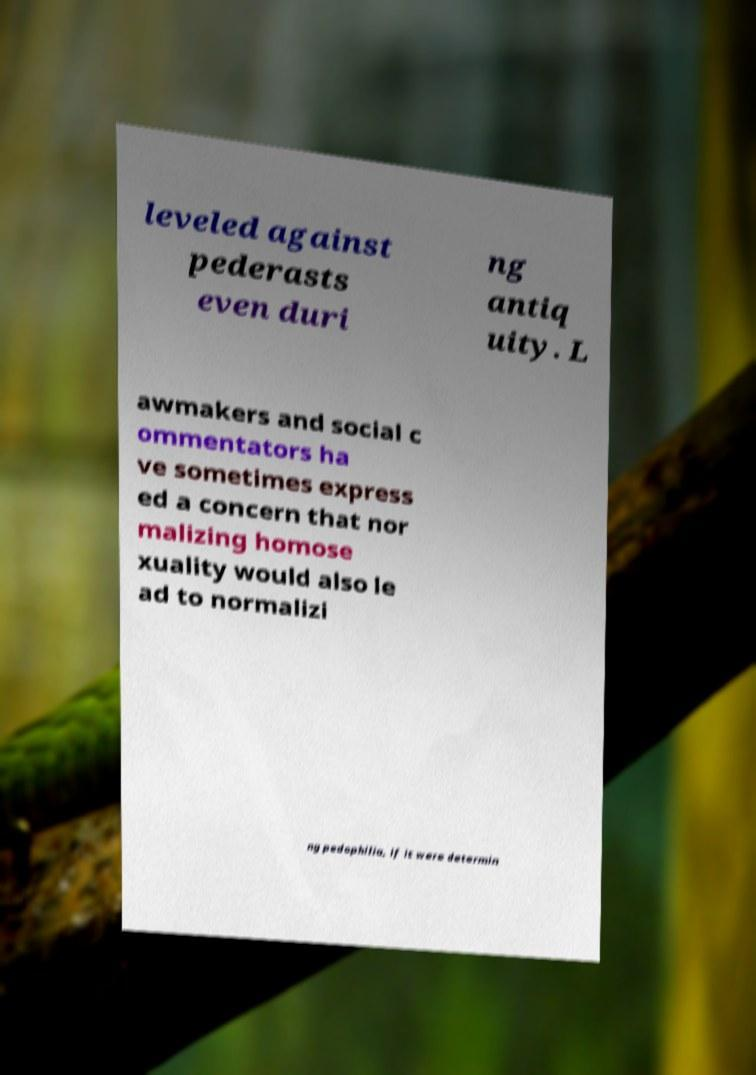I need the written content from this picture converted into text. Can you do that? leveled against pederasts even duri ng antiq uity. L awmakers and social c ommentators ha ve sometimes express ed a concern that nor malizing homose xuality would also le ad to normalizi ng pedophilia, if it were determin 